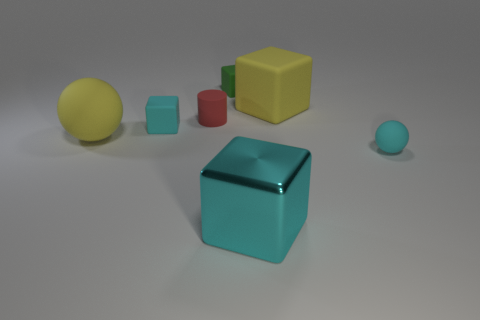Subtract 1 blocks. How many blocks are left? 3 Add 3 blocks. How many objects exist? 10 Subtract all cylinders. How many objects are left? 6 Subtract all big blue rubber balls. Subtract all cylinders. How many objects are left? 6 Add 1 green cubes. How many green cubes are left? 2 Add 7 rubber cylinders. How many rubber cylinders exist? 8 Subtract 0 blue balls. How many objects are left? 7 